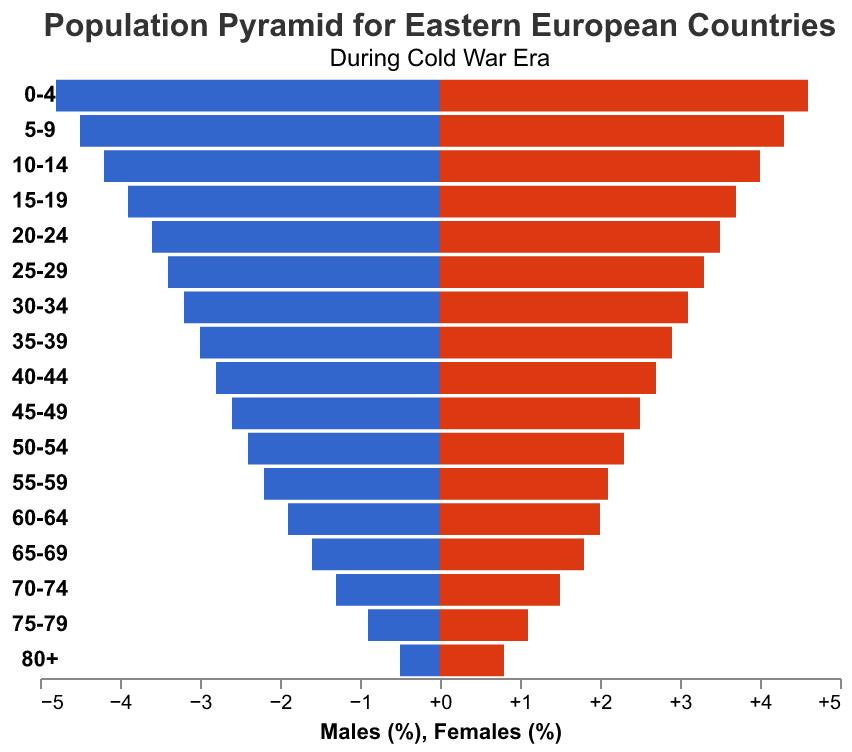What is the age group with the highest percentage of males? By visually inspecting the population pyramid, the age group with the longest bar on the left (males) is the 0-4 age group.
Answer: 0-4 Which age group has more females compared to males? By visually comparing the lengths of the bars for males and females across each age group, the age group where the female bar is longer than the male bar is the 80+ group.
Answer: 80+ How does the population percentage differ between males and females in the 60-64 age group? To find the difference, we subtract the male percentage from the female percentage for the 60-64 age group: 2.0 (Females) - 1.9 (Males) = 0.1.
Answer: 0.1 What is the total percentage of people in the age group 55-59? To find the total percentage, sum the male and female percentages for the age group 55-59: 2.2 (Males) + 2.1 (Females) = 4.3.
Answer: 4.3 Which gender has a higher percentage in the age group 20-24? By observing the bars for the 20-24 age group, the length of the male bar (3.6) is slightly longer than the female bar (3.5).
Answer: Males Is the percentage of females in the age group 65-69 higher or lower than 1.8%? From the figure, the percentage of females in the age group 65-69 shows exactly 1.8%.
Answer: Equal What is the difference in percentage between males and females in the 80+ age group? To find the difference, subtract the male percentage from the female percentage for the 80+ age group: 0.8 (Females) - 0.5 (Males) = 0.3.
Answer: 0.3 Are the percentages for males and females more balanced in the younger age groups (0-9) or older age groups (70+)? By comparing the length of bars for the youngest (0-9) and oldest (70+) age groups, the younger age groups (0-9) show a smaller difference between genders, thus more balanced.
Answer: Younger age groups (0-9) What is the general trend of the male population percentage as age increases? Observing the left side of the pyramid, the male population percentage decreases progressively as age increases, starting from 4.8% in 0-4 to 0.5% in 80+.
Answer: Decreasing Which age group has nearly equal percentages for both males and females? By looking at the bars, the age group 25-29 shows nearly equal percentages for males (3.4) and females (3.3).
Answer: 25-29 